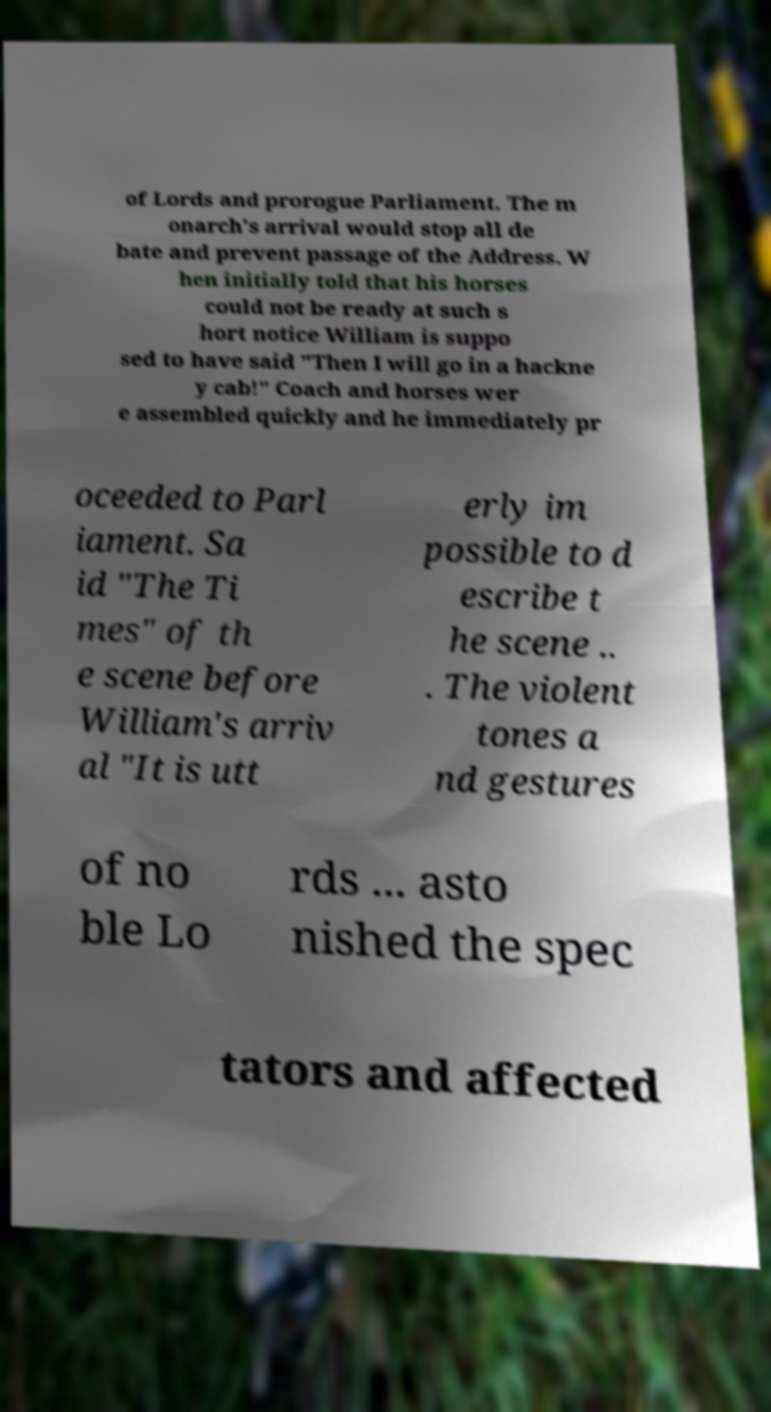Could you assist in decoding the text presented in this image and type it out clearly? of Lords and prorogue Parliament. The m onarch's arrival would stop all de bate and prevent passage of the Address. W hen initially told that his horses could not be ready at such s hort notice William is suppo sed to have said "Then I will go in a hackne y cab!" Coach and horses wer e assembled quickly and he immediately pr oceeded to Parl iament. Sa id "The Ti mes" of th e scene before William's arriv al "It is utt erly im possible to d escribe t he scene .. . The violent tones a nd gestures of no ble Lo rds ... asto nished the spec tators and affected 